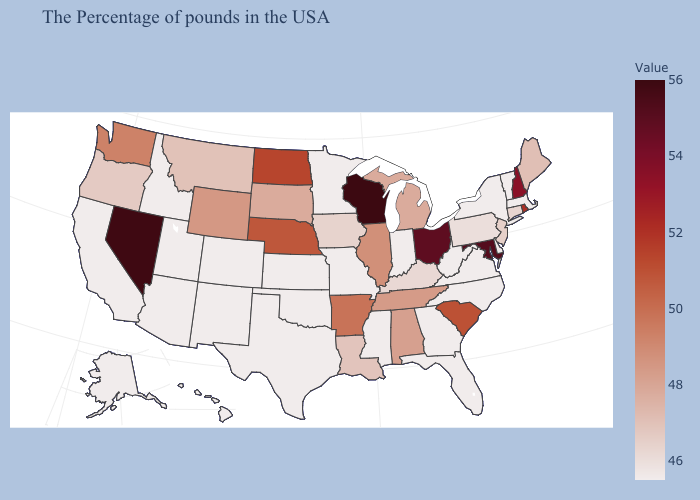Which states have the lowest value in the West?
Keep it brief. Colorado, New Mexico, Utah, Arizona, Idaho, California, Alaska, Hawaii. Among the states that border New Hampshire , does Maine have the highest value?
Short answer required. Yes. Is the legend a continuous bar?
Give a very brief answer. Yes. Does New Hampshire have the highest value in the Northeast?
Give a very brief answer. Yes. Does West Virginia have a higher value than South Dakota?
Concise answer only. No. Among the states that border Iowa , which have the lowest value?
Concise answer only. Missouri, Minnesota. 